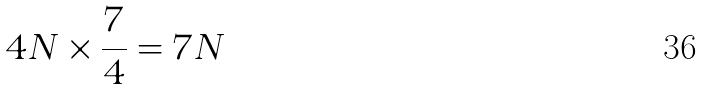Convert formula to latex. <formula><loc_0><loc_0><loc_500><loc_500>4 N \times \frac { 7 } { 4 } = 7 N</formula> 